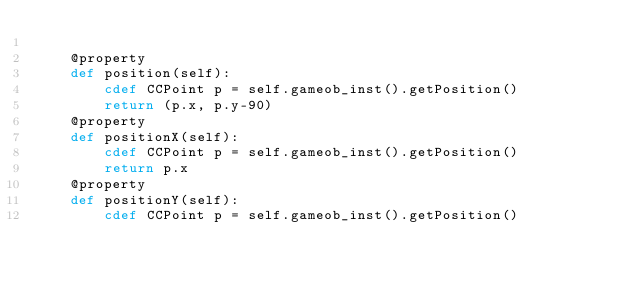<code> <loc_0><loc_0><loc_500><loc_500><_Cython_>
    @property
    def position(self):
        cdef CCPoint p = self.gameob_inst().getPosition()
        return (p.x, p.y-90)
    @property
    def positionX(self):
        cdef CCPoint p = self.gameob_inst().getPosition()
        return p.x
    @property
    def positionY(self):
        cdef CCPoint p = self.gameob_inst().getPosition()</code> 